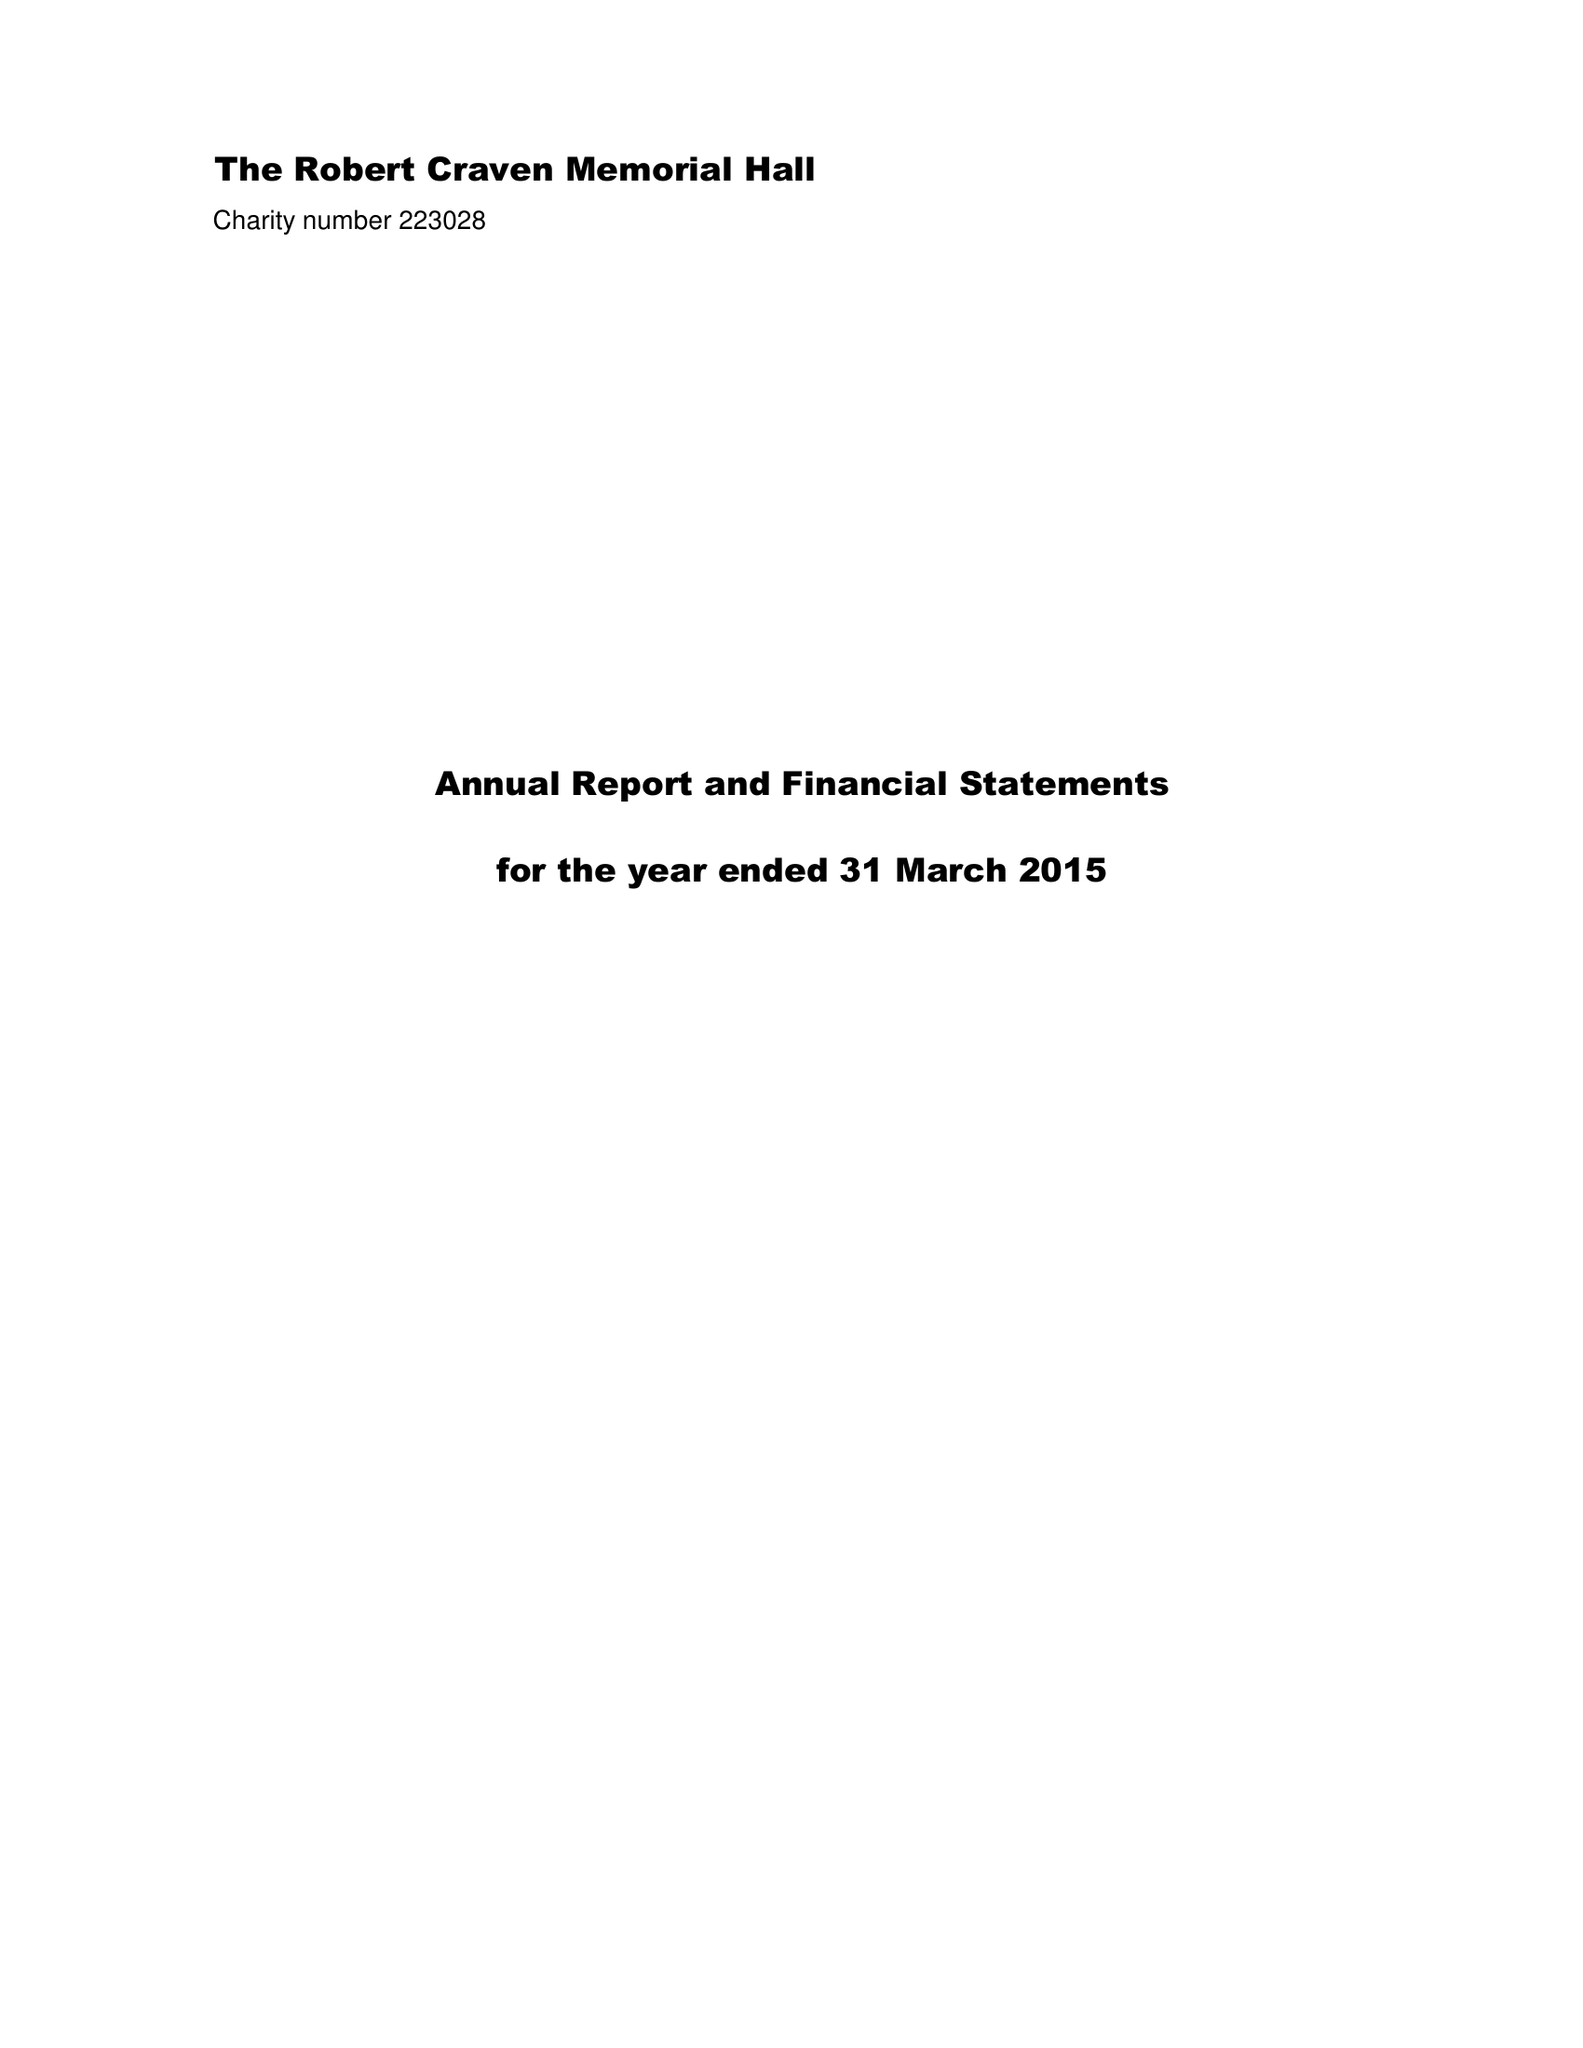What is the value for the address__street_line?
Answer the question using a single word or phrase. MOOR ROAD 